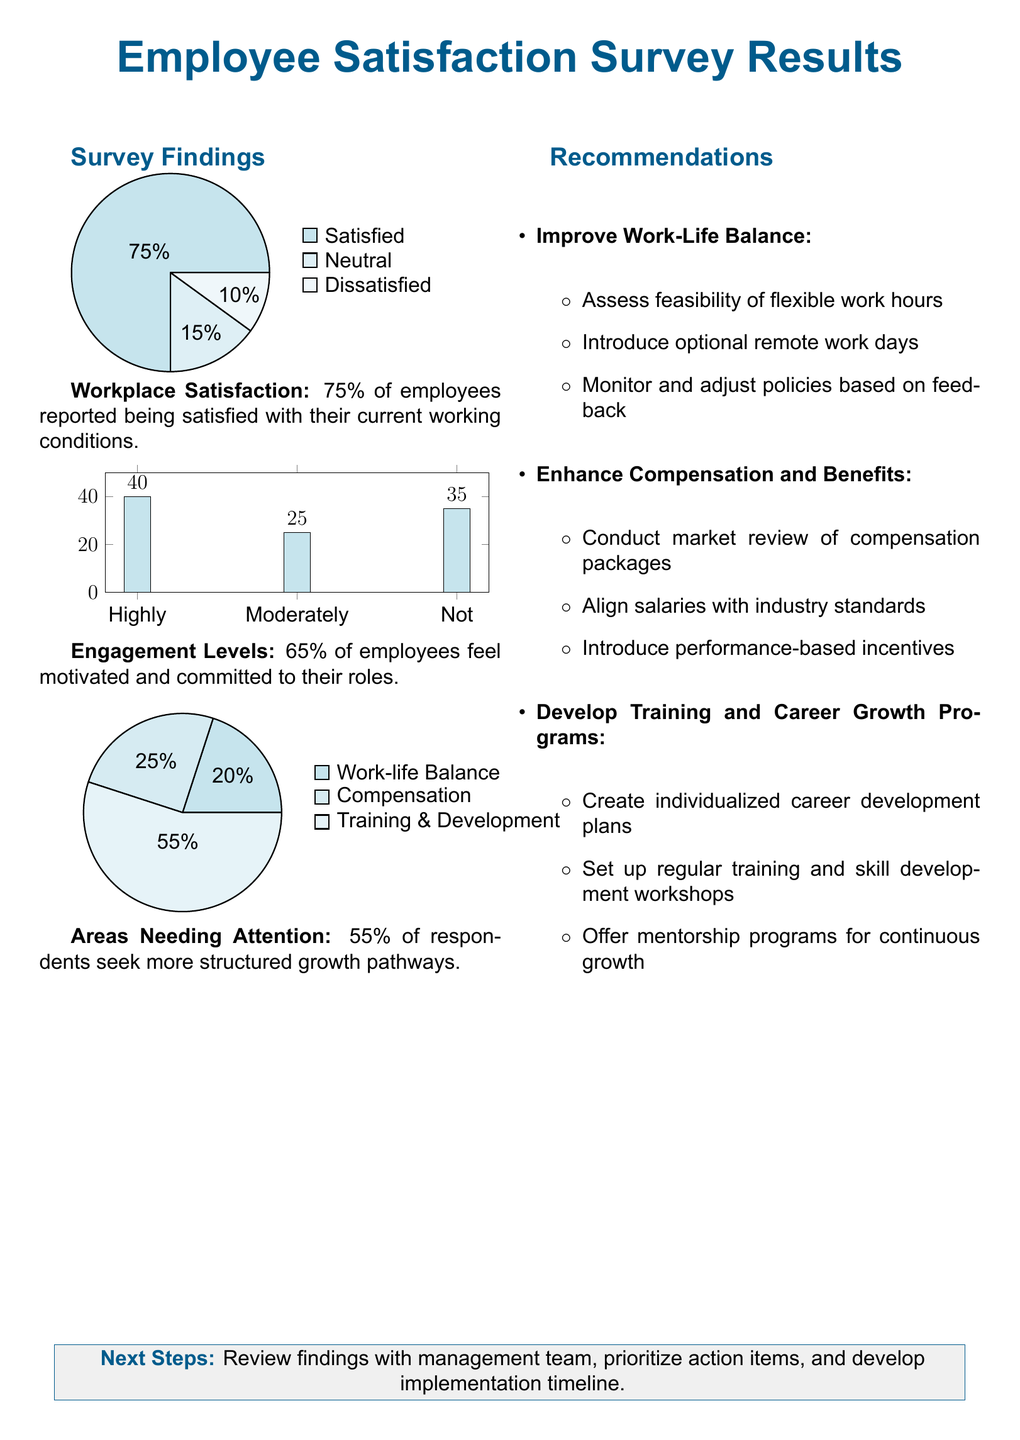What percentage of employees are satisfied? The survey indicates that 75% of employees reported being satisfied with their current working conditions.
Answer: 75% What percentage of employees feel motivated? The document states that 65% of employees feel motivated and committed to their roles.
Answer: 65% What is the primary area needing attention? According to the survey findings, 55% of respondents seek more structured growth pathways.
Answer: Structured growth pathways Which aspect requires the least attention according to the pie chart? The pie chart shows that 20% of the respondents are concerned about work-life balance, which is the least highlighted issue.
Answer: Work-life balance What recommendations are made for enhancing compensation? The recommendations include conducting a market review of compensation packages and aligning salaries with industry standards.
Answer: Conduct market review How many employees reported feeling neutral about their satisfaction? The survey shows that 15% of employees reported feeling neutral about their satisfaction.
Answer: 15% What is the highest percentage claimed for areas needing attention? The document mentions that training and development is the area with the highest percentage of attention needed at 55%.
Answer: Training & Development What should be the next steps after reviewing the findings? The next steps involve reviewing findings with the management team and prioritizing action items.
Answer: Review findings with management 